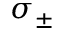<formula> <loc_0><loc_0><loc_500><loc_500>\sigma _ { \pm }</formula> 